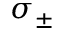<formula> <loc_0><loc_0><loc_500><loc_500>\sigma _ { \pm }</formula> 